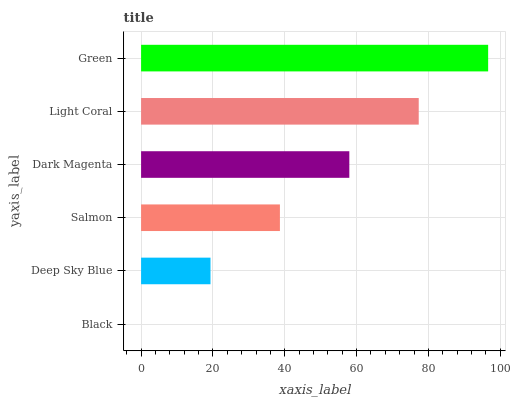Is Black the minimum?
Answer yes or no. Yes. Is Green the maximum?
Answer yes or no. Yes. Is Deep Sky Blue the minimum?
Answer yes or no. No. Is Deep Sky Blue the maximum?
Answer yes or no. No. Is Deep Sky Blue greater than Black?
Answer yes or no. Yes. Is Black less than Deep Sky Blue?
Answer yes or no. Yes. Is Black greater than Deep Sky Blue?
Answer yes or no. No. Is Deep Sky Blue less than Black?
Answer yes or no. No. Is Dark Magenta the high median?
Answer yes or no. Yes. Is Salmon the low median?
Answer yes or no. Yes. Is Green the high median?
Answer yes or no. No. Is Dark Magenta the low median?
Answer yes or no. No. 